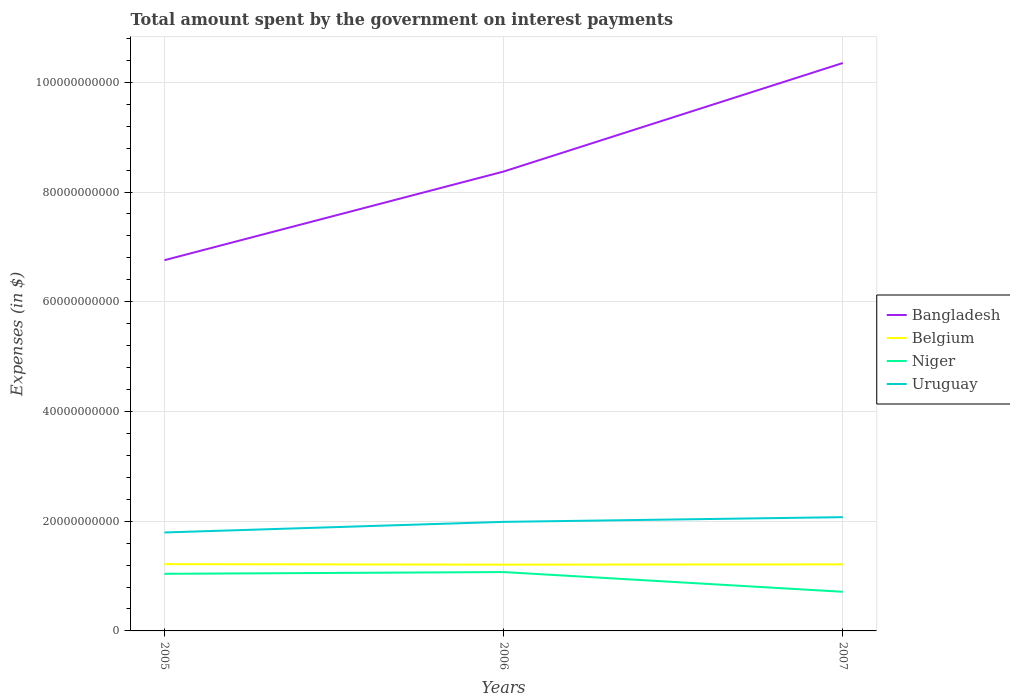Does the line corresponding to Uruguay intersect with the line corresponding to Belgium?
Provide a short and direct response. No. Across all years, what is the maximum amount spent on interest payments by the government in Niger?
Offer a terse response. 7.13e+09. In which year was the amount spent on interest payments by the government in Niger maximum?
Make the answer very short. 2007. What is the total amount spent on interest payments by the government in Belgium in the graph?
Keep it short and to the point. 4.20e+07. What is the difference between the highest and the second highest amount spent on interest payments by the government in Uruguay?
Offer a terse response. 2.79e+09. How many lines are there?
Make the answer very short. 4. How many years are there in the graph?
Give a very brief answer. 3. What is the difference between two consecutive major ticks on the Y-axis?
Provide a short and direct response. 2.00e+1. Does the graph contain any zero values?
Provide a short and direct response. No. Does the graph contain grids?
Provide a succinct answer. Yes. How many legend labels are there?
Make the answer very short. 4. What is the title of the graph?
Your answer should be compact. Total amount spent by the government on interest payments. What is the label or title of the X-axis?
Your response must be concise. Years. What is the label or title of the Y-axis?
Make the answer very short. Expenses (in $). What is the Expenses (in $) in Bangladesh in 2005?
Your response must be concise. 6.76e+1. What is the Expenses (in $) of Belgium in 2005?
Keep it short and to the point. 1.22e+1. What is the Expenses (in $) of Niger in 2005?
Your answer should be very brief. 1.04e+1. What is the Expenses (in $) in Uruguay in 2005?
Make the answer very short. 1.79e+1. What is the Expenses (in $) of Bangladesh in 2006?
Offer a terse response. 8.37e+1. What is the Expenses (in $) of Belgium in 2006?
Provide a succinct answer. 1.21e+1. What is the Expenses (in $) in Niger in 2006?
Your response must be concise. 1.07e+1. What is the Expenses (in $) in Uruguay in 2006?
Keep it short and to the point. 1.99e+1. What is the Expenses (in $) in Bangladesh in 2007?
Provide a short and direct response. 1.04e+11. What is the Expenses (in $) in Belgium in 2007?
Keep it short and to the point. 1.21e+1. What is the Expenses (in $) of Niger in 2007?
Give a very brief answer. 7.13e+09. What is the Expenses (in $) in Uruguay in 2007?
Offer a terse response. 2.07e+1. Across all years, what is the maximum Expenses (in $) in Bangladesh?
Offer a terse response. 1.04e+11. Across all years, what is the maximum Expenses (in $) of Belgium?
Give a very brief answer. 1.22e+1. Across all years, what is the maximum Expenses (in $) in Niger?
Ensure brevity in your answer.  1.07e+1. Across all years, what is the maximum Expenses (in $) of Uruguay?
Offer a terse response. 2.07e+1. Across all years, what is the minimum Expenses (in $) in Bangladesh?
Provide a short and direct response. 6.76e+1. Across all years, what is the minimum Expenses (in $) of Belgium?
Give a very brief answer. 1.21e+1. Across all years, what is the minimum Expenses (in $) of Niger?
Ensure brevity in your answer.  7.13e+09. Across all years, what is the minimum Expenses (in $) in Uruguay?
Ensure brevity in your answer.  1.79e+1. What is the total Expenses (in $) in Bangladesh in the graph?
Provide a succinct answer. 2.55e+11. What is the total Expenses (in $) in Belgium in the graph?
Provide a succinct answer. 3.64e+1. What is the total Expenses (in $) in Niger in the graph?
Provide a short and direct response. 2.83e+1. What is the total Expenses (in $) of Uruguay in the graph?
Offer a terse response. 5.86e+1. What is the difference between the Expenses (in $) in Bangladesh in 2005 and that in 2006?
Your answer should be compact. -1.62e+1. What is the difference between the Expenses (in $) in Belgium in 2005 and that in 2006?
Your answer should be compact. 9.46e+07. What is the difference between the Expenses (in $) in Niger in 2005 and that in 2006?
Give a very brief answer. -3.18e+08. What is the difference between the Expenses (in $) of Uruguay in 2005 and that in 2006?
Offer a very short reply. -1.93e+09. What is the difference between the Expenses (in $) of Bangladesh in 2005 and that in 2007?
Make the answer very short. -3.59e+1. What is the difference between the Expenses (in $) in Belgium in 2005 and that in 2007?
Ensure brevity in your answer.  4.20e+07. What is the difference between the Expenses (in $) of Niger in 2005 and that in 2007?
Provide a succinct answer. 3.28e+09. What is the difference between the Expenses (in $) in Uruguay in 2005 and that in 2007?
Your answer should be very brief. -2.79e+09. What is the difference between the Expenses (in $) of Bangladesh in 2006 and that in 2007?
Your answer should be very brief. -1.98e+1. What is the difference between the Expenses (in $) in Belgium in 2006 and that in 2007?
Ensure brevity in your answer.  -5.26e+07. What is the difference between the Expenses (in $) in Niger in 2006 and that in 2007?
Provide a succinct answer. 3.59e+09. What is the difference between the Expenses (in $) in Uruguay in 2006 and that in 2007?
Offer a terse response. -8.55e+08. What is the difference between the Expenses (in $) in Bangladesh in 2005 and the Expenses (in $) in Belgium in 2006?
Give a very brief answer. 5.55e+1. What is the difference between the Expenses (in $) of Bangladesh in 2005 and the Expenses (in $) of Niger in 2006?
Your answer should be very brief. 5.68e+1. What is the difference between the Expenses (in $) in Bangladesh in 2005 and the Expenses (in $) in Uruguay in 2006?
Provide a succinct answer. 4.77e+1. What is the difference between the Expenses (in $) of Belgium in 2005 and the Expenses (in $) of Niger in 2006?
Ensure brevity in your answer.  1.45e+09. What is the difference between the Expenses (in $) of Belgium in 2005 and the Expenses (in $) of Uruguay in 2006?
Ensure brevity in your answer.  -7.71e+09. What is the difference between the Expenses (in $) in Niger in 2005 and the Expenses (in $) in Uruguay in 2006?
Give a very brief answer. -9.47e+09. What is the difference between the Expenses (in $) of Bangladesh in 2005 and the Expenses (in $) of Belgium in 2007?
Provide a short and direct response. 5.54e+1. What is the difference between the Expenses (in $) in Bangladesh in 2005 and the Expenses (in $) in Niger in 2007?
Provide a short and direct response. 6.04e+1. What is the difference between the Expenses (in $) of Bangladesh in 2005 and the Expenses (in $) of Uruguay in 2007?
Your answer should be compact. 4.68e+1. What is the difference between the Expenses (in $) in Belgium in 2005 and the Expenses (in $) in Niger in 2007?
Provide a short and direct response. 5.04e+09. What is the difference between the Expenses (in $) in Belgium in 2005 and the Expenses (in $) in Uruguay in 2007?
Make the answer very short. -8.56e+09. What is the difference between the Expenses (in $) in Niger in 2005 and the Expenses (in $) in Uruguay in 2007?
Give a very brief answer. -1.03e+1. What is the difference between the Expenses (in $) of Bangladesh in 2006 and the Expenses (in $) of Belgium in 2007?
Your response must be concise. 7.16e+1. What is the difference between the Expenses (in $) in Bangladesh in 2006 and the Expenses (in $) in Niger in 2007?
Give a very brief answer. 7.66e+1. What is the difference between the Expenses (in $) in Bangladesh in 2006 and the Expenses (in $) in Uruguay in 2007?
Ensure brevity in your answer.  6.30e+1. What is the difference between the Expenses (in $) in Belgium in 2006 and the Expenses (in $) in Niger in 2007?
Your answer should be compact. 4.95e+09. What is the difference between the Expenses (in $) in Belgium in 2006 and the Expenses (in $) in Uruguay in 2007?
Keep it short and to the point. -8.66e+09. What is the difference between the Expenses (in $) of Niger in 2006 and the Expenses (in $) of Uruguay in 2007?
Provide a short and direct response. -1.00e+1. What is the average Expenses (in $) in Bangladesh per year?
Ensure brevity in your answer.  8.49e+1. What is the average Expenses (in $) in Belgium per year?
Offer a very short reply. 1.21e+1. What is the average Expenses (in $) of Niger per year?
Give a very brief answer. 9.42e+09. What is the average Expenses (in $) of Uruguay per year?
Make the answer very short. 1.95e+1. In the year 2005, what is the difference between the Expenses (in $) in Bangladesh and Expenses (in $) in Belgium?
Provide a short and direct response. 5.54e+1. In the year 2005, what is the difference between the Expenses (in $) in Bangladesh and Expenses (in $) in Niger?
Offer a very short reply. 5.72e+1. In the year 2005, what is the difference between the Expenses (in $) in Bangladesh and Expenses (in $) in Uruguay?
Offer a terse response. 4.96e+1. In the year 2005, what is the difference between the Expenses (in $) in Belgium and Expenses (in $) in Niger?
Offer a terse response. 1.76e+09. In the year 2005, what is the difference between the Expenses (in $) in Belgium and Expenses (in $) in Uruguay?
Your answer should be compact. -5.77e+09. In the year 2005, what is the difference between the Expenses (in $) of Niger and Expenses (in $) of Uruguay?
Your answer should be very brief. -7.54e+09. In the year 2006, what is the difference between the Expenses (in $) of Bangladesh and Expenses (in $) of Belgium?
Provide a succinct answer. 7.17e+1. In the year 2006, what is the difference between the Expenses (in $) of Bangladesh and Expenses (in $) of Niger?
Provide a short and direct response. 7.30e+1. In the year 2006, what is the difference between the Expenses (in $) in Bangladesh and Expenses (in $) in Uruguay?
Your answer should be compact. 6.39e+1. In the year 2006, what is the difference between the Expenses (in $) of Belgium and Expenses (in $) of Niger?
Your answer should be very brief. 1.35e+09. In the year 2006, what is the difference between the Expenses (in $) of Belgium and Expenses (in $) of Uruguay?
Offer a very short reply. -7.80e+09. In the year 2006, what is the difference between the Expenses (in $) in Niger and Expenses (in $) in Uruguay?
Ensure brevity in your answer.  -9.15e+09. In the year 2007, what is the difference between the Expenses (in $) in Bangladesh and Expenses (in $) in Belgium?
Your answer should be compact. 9.14e+1. In the year 2007, what is the difference between the Expenses (in $) in Bangladesh and Expenses (in $) in Niger?
Your answer should be compact. 9.64e+1. In the year 2007, what is the difference between the Expenses (in $) of Bangladesh and Expenses (in $) of Uruguay?
Offer a very short reply. 8.28e+1. In the year 2007, what is the difference between the Expenses (in $) in Belgium and Expenses (in $) in Niger?
Keep it short and to the point. 5.00e+09. In the year 2007, what is the difference between the Expenses (in $) in Belgium and Expenses (in $) in Uruguay?
Offer a terse response. -8.60e+09. In the year 2007, what is the difference between the Expenses (in $) in Niger and Expenses (in $) in Uruguay?
Ensure brevity in your answer.  -1.36e+1. What is the ratio of the Expenses (in $) in Bangladesh in 2005 to that in 2006?
Keep it short and to the point. 0.81. What is the ratio of the Expenses (in $) of Belgium in 2005 to that in 2006?
Provide a short and direct response. 1.01. What is the ratio of the Expenses (in $) of Niger in 2005 to that in 2006?
Provide a succinct answer. 0.97. What is the ratio of the Expenses (in $) in Uruguay in 2005 to that in 2006?
Keep it short and to the point. 0.9. What is the ratio of the Expenses (in $) of Bangladesh in 2005 to that in 2007?
Offer a terse response. 0.65. What is the ratio of the Expenses (in $) of Belgium in 2005 to that in 2007?
Keep it short and to the point. 1. What is the ratio of the Expenses (in $) of Niger in 2005 to that in 2007?
Ensure brevity in your answer.  1.46. What is the ratio of the Expenses (in $) of Uruguay in 2005 to that in 2007?
Offer a very short reply. 0.87. What is the ratio of the Expenses (in $) of Bangladesh in 2006 to that in 2007?
Your answer should be very brief. 0.81. What is the ratio of the Expenses (in $) in Niger in 2006 to that in 2007?
Ensure brevity in your answer.  1.5. What is the ratio of the Expenses (in $) of Uruguay in 2006 to that in 2007?
Your answer should be very brief. 0.96. What is the difference between the highest and the second highest Expenses (in $) of Bangladesh?
Ensure brevity in your answer.  1.98e+1. What is the difference between the highest and the second highest Expenses (in $) of Belgium?
Your response must be concise. 4.20e+07. What is the difference between the highest and the second highest Expenses (in $) of Niger?
Offer a terse response. 3.18e+08. What is the difference between the highest and the second highest Expenses (in $) in Uruguay?
Provide a succinct answer. 8.55e+08. What is the difference between the highest and the lowest Expenses (in $) in Bangladesh?
Offer a very short reply. 3.59e+1. What is the difference between the highest and the lowest Expenses (in $) in Belgium?
Provide a succinct answer. 9.46e+07. What is the difference between the highest and the lowest Expenses (in $) of Niger?
Your answer should be very brief. 3.59e+09. What is the difference between the highest and the lowest Expenses (in $) in Uruguay?
Your answer should be compact. 2.79e+09. 